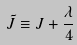Convert formula to latex. <formula><loc_0><loc_0><loc_500><loc_500>\tilde { J } \equiv J + \frac { \lambda } { 4 }</formula> 